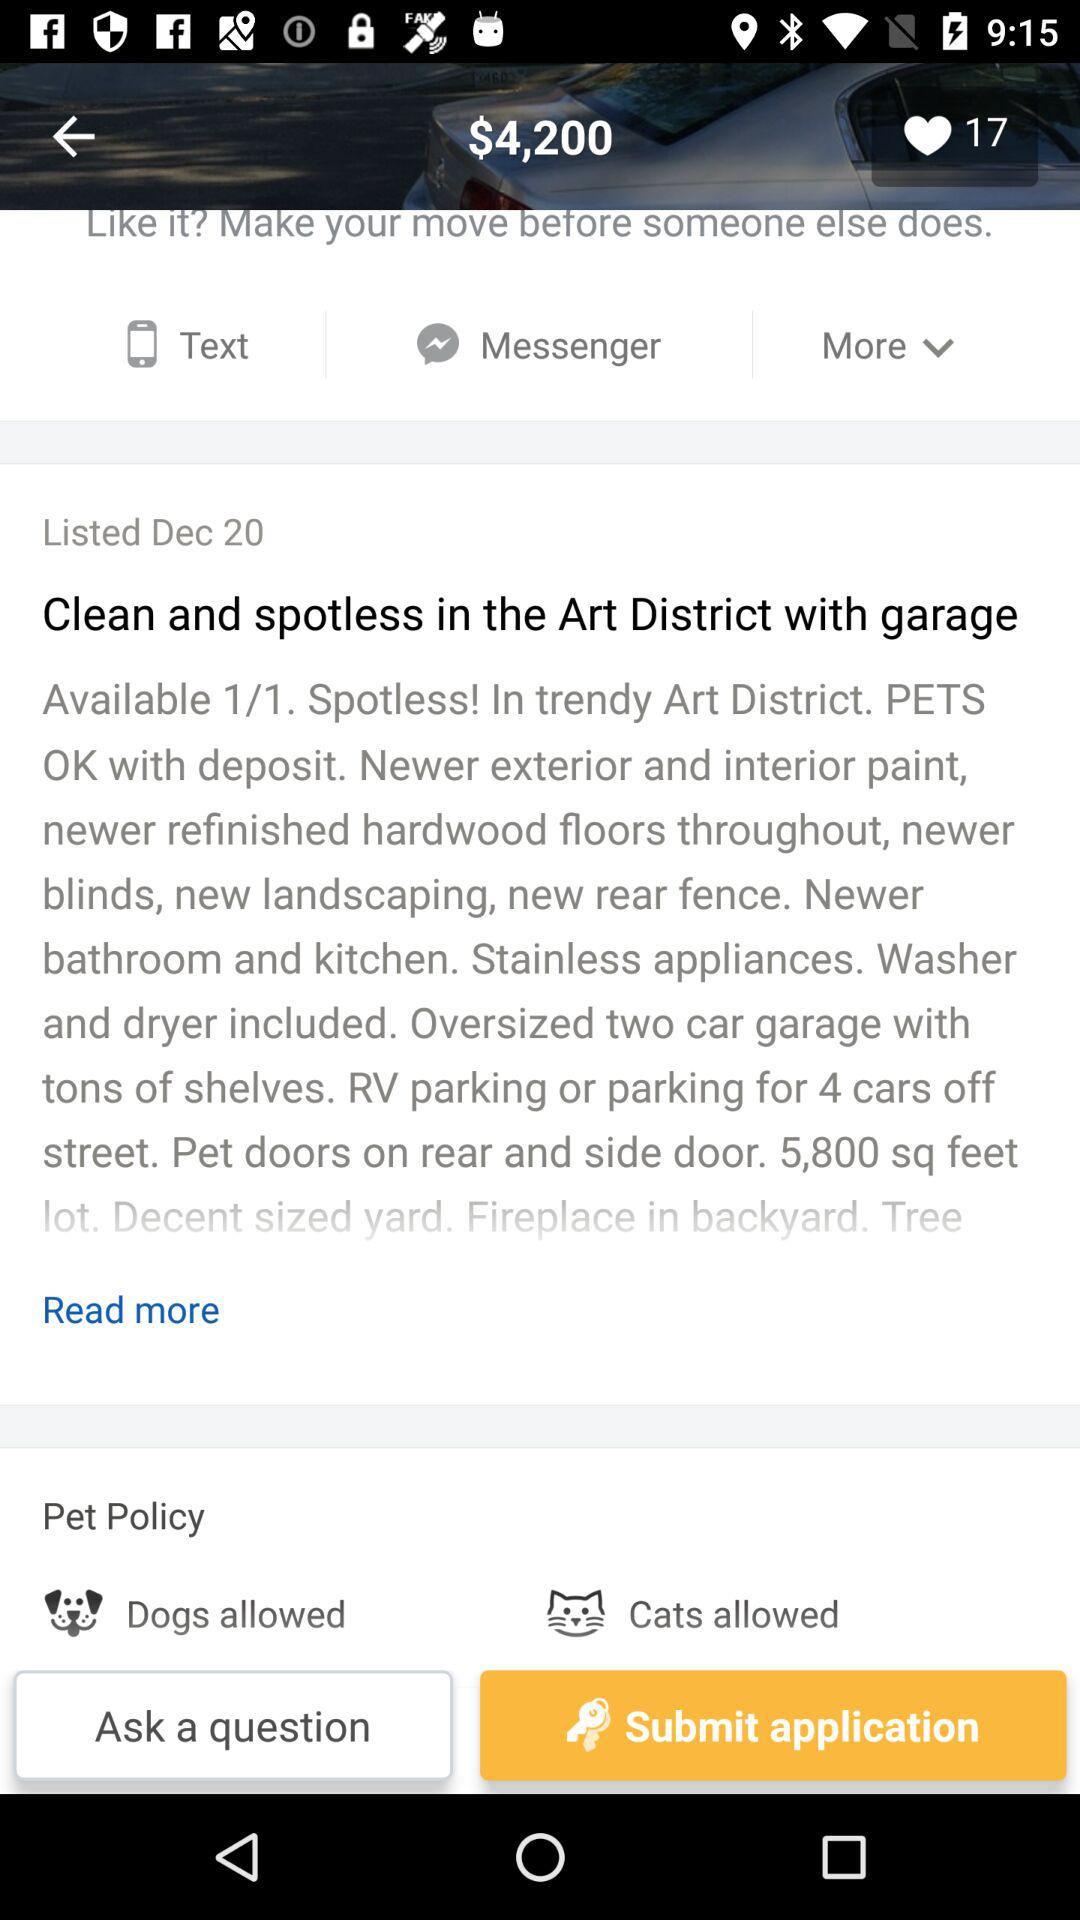What is the amount given? The amount given is $4,200. 